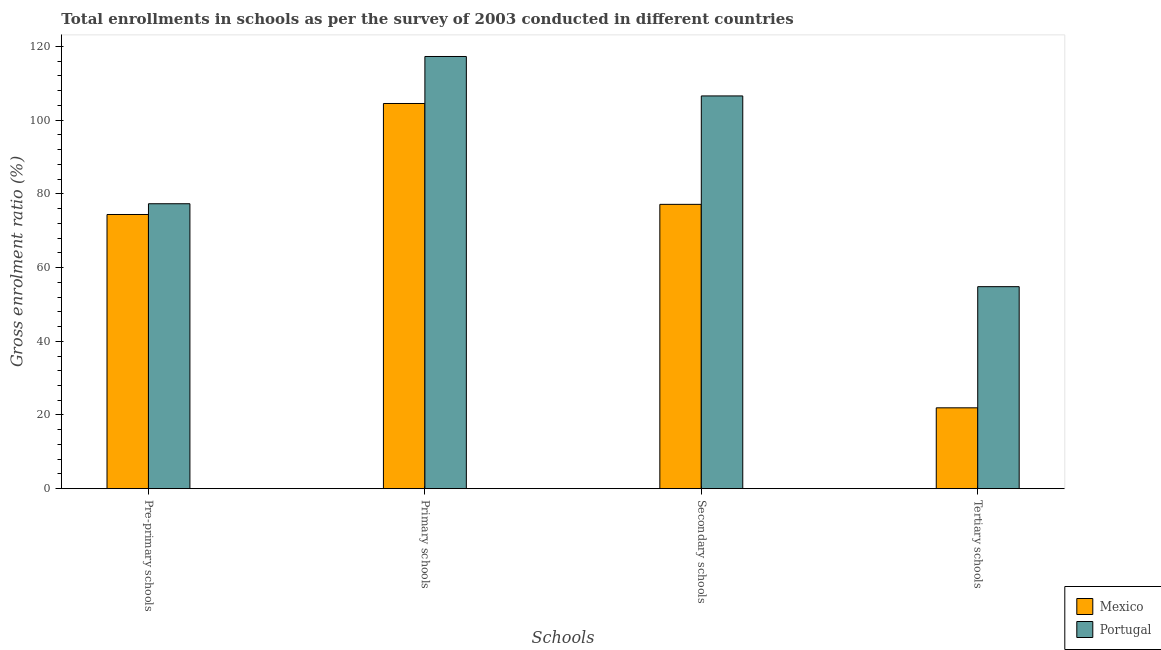How many groups of bars are there?
Provide a short and direct response. 4. Are the number of bars per tick equal to the number of legend labels?
Provide a succinct answer. Yes. Are the number of bars on each tick of the X-axis equal?
Make the answer very short. Yes. How many bars are there on the 1st tick from the right?
Ensure brevity in your answer.  2. What is the label of the 4th group of bars from the left?
Provide a short and direct response. Tertiary schools. What is the gross enrolment ratio in primary schools in Portugal?
Keep it short and to the point. 117.28. Across all countries, what is the maximum gross enrolment ratio in pre-primary schools?
Provide a short and direct response. 77.32. Across all countries, what is the minimum gross enrolment ratio in pre-primary schools?
Offer a very short reply. 74.4. In which country was the gross enrolment ratio in pre-primary schools maximum?
Your answer should be compact. Portugal. In which country was the gross enrolment ratio in pre-primary schools minimum?
Make the answer very short. Mexico. What is the total gross enrolment ratio in secondary schools in the graph?
Your answer should be very brief. 183.73. What is the difference between the gross enrolment ratio in pre-primary schools in Mexico and that in Portugal?
Offer a terse response. -2.92. What is the difference between the gross enrolment ratio in secondary schools in Mexico and the gross enrolment ratio in tertiary schools in Portugal?
Your answer should be compact. 22.34. What is the average gross enrolment ratio in primary schools per country?
Provide a short and direct response. 110.9. What is the difference between the gross enrolment ratio in primary schools and gross enrolment ratio in tertiary schools in Mexico?
Give a very brief answer. 82.58. What is the ratio of the gross enrolment ratio in pre-primary schools in Mexico to that in Portugal?
Ensure brevity in your answer.  0.96. What is the difference between the highest and the second highest gross enrolment ratio in primary schools?
Offer a terse response. 12.76. What is the difference between the highest and the lowest gross enrolment ratio in tertiary schools?
Your answer should be compact. 32.88. Is the sum of the gross enrolment ratio in tertiary schools in Mexico and Portugal greater than the maximum gross enrolment ratio in pre-primary schools across all countries?
Your response must be concise. No. What does the 1st bar from the left in Pre-primary schools represents?
Ensure brevity in your answer.  Mexico. Is it the case that in every country, the sum of the gross enrolment ratio in pre-primary schools and gross enrolment ratio in primary schools is greater than the gross enrolment ratio in secondary schools?
Your answer should be compact. Yes. How many bars are there?
Ensure brevity in your answer.  8. How many countries are there in the graph?
Keep it short and to the point. 2. What is the difference between two consecutive major ticks on the Y-axis?
Provide a short and direct response. 20. How are the legend labels stacked?
Keep it short and to the point. Vertical. What is the title of the graph?
Ensure brevity in your answer.  Total enrollments in schools as per the survey of 2003 conducted in different countries. Does "Gambia, The" appear as one of the legend labels in the graph?
Keep it short and to the point. No. What is the label or title of the X-axis?
Keep it short and to the point. Schools. What is the Gross enrolment ratio (%) of Mexico in Pre-primary schools?
Your answer should be very brief. 74.4. What is the Gross enrolment ratio (%) in Portugal in Pre-primary schools?
Offer a terse response. 77.32. What is the Gross enrolment ratio (%) of Mexico in Primary schools?
Ensure brevity in your answer.  104.52. What is the Gross enrolment ratio (%) of Portugal in Primary schools?
Keep it short and to the point. 117.28. What is the Gross enrolment ratio (%) in Mexico in Secondary schools?
Provide a succinct answer. 77.16. What is the Gross enrolment ratio (%) in Portugal in Secondary schools?
Your answer should be very brief. 106.57. What is the Gross enrolment ratio (%) of Mexico in Tertiary schools?
Offer a very short reply. 21.94. What is the Gross enrolment ratio (%) in Portugal in Tertiary schools?
Ensure brevity in your answer.  54.82. Across all Schools, what is the maximum Gross enrolment ratio (%) in Mexico?
Provide a short and direct response. 104.52. Across all Schools, what is the maximum Gross enrolment ratio (%) in Portugal?
Your answer should be very brief. 117.28. Across all Schools, what is the minimum Gross enrolment ratio (%) of Mexico?
Make the answer very short. 21.94. Across all Schools, what is the minimum Gross enrolment ratio (%) in Portugal?
Offer a terse response. 54.82. What is the total Gross enrolment ratio (%) in Mexico in the graph?
Ensure brevity in your answer.  278.02. What is the total Gross enrolment ratio (%) of Portugal in the graph?
Provide a succinct answer. 355.99. What is the difference between the Gross enrolment ratio (%) of Mexico in Pre-primary schools and that in Primary schools?
Give a very brief answer. -30.12. What is the difference between the Gross enrolment ratio (%) in Portugal in Pre-primary schools and that in Primary schools?
Make the answer very short. -39.96. What is the difference between the Gross enrolment ratio (%) in Mexico in Pre-primary schools and that in Secondary schools?
Your answer should be compact. -2.75. What is the difference between the Gross enrolment ratio (%) of Portugal in Pre-primary schools and that in Secondary schools?
Provide a short and direct response. -29.25. What is the difference between the Gross enrolment ratio (%) of Mexico in Pre-primary schools and that in Tertiary schools?
Provide a succinct answer. 52.46. What is the difference between the Gross enrolment ratio (%) of Portugal in Pre-primary schools and that in Tertiary schools?
Offer a terse response. 22.5. What is the difference between the Gross enrolment ratio (%) of Mexico in Primary schools and that in Secondary schools?
Your answer should be compact. 27.37. What is the difference between the Gross enrolment ratio (%) in Portugal in Primary schools and that in Secondary schools?
Your answer should be compact. 10.7. What is the difference between the Gross enrolment ratio (%) of Mexico in Primary schools and that in Tertiary schools?
Your response must be concise. 82.58. What is the difference between the Gross enrolment ratio (%) in Portugal in Primary schools and that in Tertiary schools?
Your answer should be compact. 62.46. What is the difference between the Gross enrolment ratio (%) in Mexico in Secondary schools and that in Tertiary schools?
Ensure brevity in your answer.  55.21. What is the difference between the Gross enrolment ratio (%) of Portugal in Secondary schools and that in Tertiary schools?
Ensure brevity in your answer.  51.76. What is the difference between the Gross enrolment ratio (%) of Mexico in Pre-primary schools and the Gross enrolment ratio (%) of Portugal in Primary schools?
Offer a very short reply. -42.87. What is the difference between the Gross enrolment ratio (%) of Mexico in Pre-primary schools and the Gross enrolment ratio (%) of Portugal in Secondary schools?
Your answer should be compact. -32.17. What is the difference between the Gross enrolment ratio (%) of Mexico in Pre-primary schools and the Gross enrolment ratio (%) of Portugal in Tertiary schools?
Offer a terse response. 19.59. What is the difference between the Gross enrolment ratio (%) of Mexico in Primary schools and the Gross enrolment ratio (%) of Portugal in Secondary schools?
Your answer should be compact. -2.05. What is the difference between the Gross enrolment ratio (%) of Mexico in Primary schools and the Gross enrolment ratio (%) of Portugal in Tertiary schools?
Provide a succinct answer. 49.71. What is the difference between the Gross enrolment ratio (%) in Mexico in Secondary schools and the Gross enrolment ratio (%) in Portugal in Tertiary schools?
Keep it short and to the point. 22.34. What is the average Gross enrolment ratio (%) of Mexico per Schools?
Your answer should be very brief. 69.51. What is the average Gross enrolment ratio (%) of Portugal per Schools?
Offer a terse response. 89. What is the difference between the Gross enrolment ratio (%) in Mexico and Gross enrolment ratio (%) in Portugal in Pre-primary schools?
Give a very brief answer. -2.92. What is the difference between the Gross enrolment ratio (%) of Mexico and Gross enrolment ratio (%) of Portugal in Primary schools?
Your answer should be very brief. -12.76. What is the difference between the Gross enrolment ratio (%) of Mexico and Gross enrolment ratio (%) of Portugal in Secondary schools?
Offer a very short reply. -29.42. What is the difference between the Gross enrolment ratio (%) of Mexico and Gross enrolment ratio (%) of Portugal in Tertiary schools?
Offer a very short reply. -32.88. What is the ratio of the Gross enrolment ratio (%) of Mexico in Pre-primary schools to that in Primary schools?
Offer a very short reply. 0.71. What is the ratio of the Gross enrolment ratio (%) in Portugal in Pre-primary schools to that in Primary schools?
Your response must be concise. 0.66. What is the ratio of the Gross enrolment ratio (%) of Mexico in Pre-primary schools to that in Secondary schools?
Give a very brief answer. 0.96. What is the ratio of the Gross enrolment ratio (%) of Portugal in Pre-primary schools to that in Secondary schools?
Offer a terse response. 0.73. What is the ratio of the Gross enrolment ratio (%) in Mexico in Pre-primary schools to that in Tertiary schools?
Your answer should be compact. 3.39. What is the ratio of the Gross enrolment ratio (%) of Portugal in Pre-primary schools to that in Tertiary schools?
Provide a short and direct response. 1.41. What is the ratio of the Gross enrolment ratio (%) of Mexico in Primary schools to that in Secondary schools?
Give a very brief answer. 1.35. What is the ratio of the Gross enrolment ratio (%) in Portugal in Primary schools to that in Secondary schools?
Your answer should be very brief. 1.1. What is the ratio of the Gross enrolment ratio (%) of Mexico in Primary schools to that in Tertiary schools?
Give a very brief answer. 4.76. What is the ratio of the Gross enrolment ratio (%) of Portugal in Primary schools to that in Tertiary schools?
Your answer should be very brief. 2.14. What is the ratio of the Gross enrolment ratio (%) of Mexico in Secondary schools to that in Tertiary schools?
Ensure brevity in your answer.  3.52. What is the ratio of the Gross enrolment ratio (%) in Portugal in Secondary schools to that in Tertiary schools?
Make the answer very short. 1.94. What is the difference between the highest and the second highest Gross enrolment ratio (%) in Mexico?
Provide a short and direct response. 27.37. What is the difference between the highest and the second highest Gross enrolment ratio (%) of Portugal?
Give a very brief answer. 10.7. What is the difference between the highest and the lowest Gross enrolment ratio (%) in Mexico?
Offer a very short reply. 82.58. What is the difference between the highest and the lowest Gross enrolment ratio (%) of Portugal?
Your response must be concise. 62.46. 